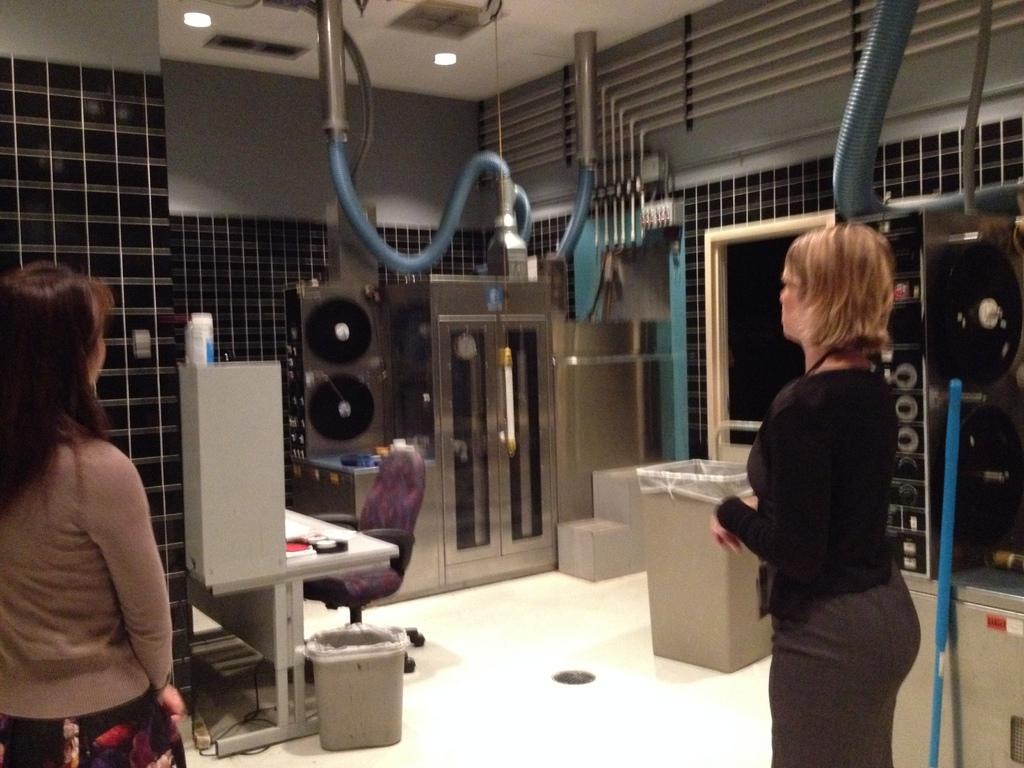What can be seen in the image regarding people? There are women standing in the image. What type of furniture is present in the image? There is a chair and a table in the image. What objects are used for waste disposal in the image? There are dustbins in the image. What type of equipment is present in the image? There are machines in the image. What type of lighting is present in the image? There are lights on the ceiling in the image. How many wrens are sitting on the machines in the image? There are no wrens present in the image, so it is not possible to determine the number of wrens. 